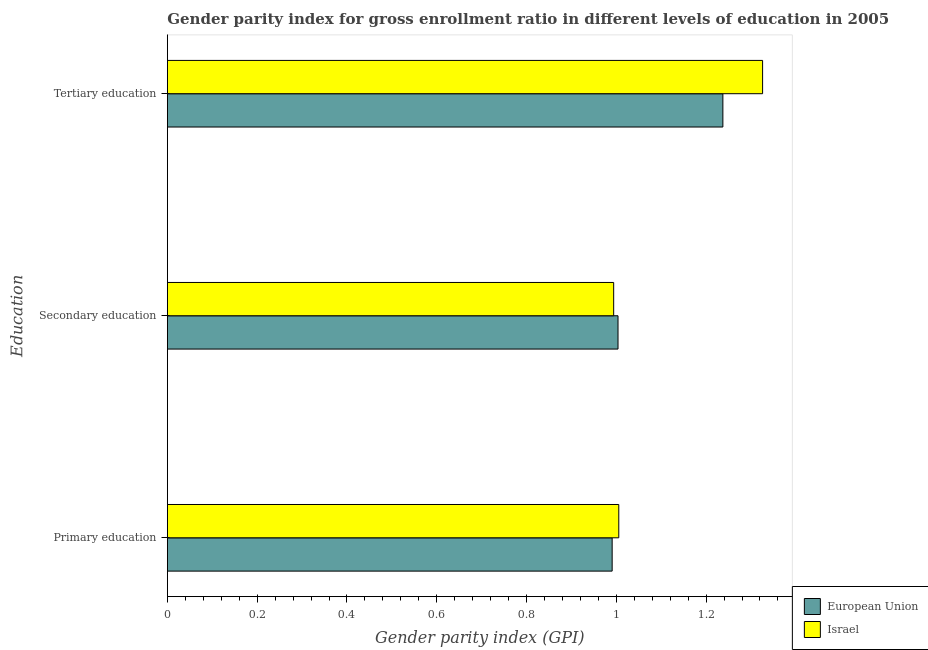How many groups of bars are there?
Provide a succinct answer. 3. Are the number of bars per tick equal to the number of legend labels?
Provide a short and direct response. Yes. How many bars are there on the 2nd tick from the top?
Your answer should be compact. 2. What is the label of the 1st group of bars from the top?
Your answer should be compact. Tertiary education. What is the gender parity index in primary education in Israel?
Offer a terse response. 1.01. Across all countries, what is the maximum gender parity index in secondary education?
Your answer should be very brief. 1. Across all countries, what is the minimum gender parity index in tertiary education?
Your answer should be very brief. 1.24. In which country was the gender parity index in secondary education maximum?
Provide a short and direct response. European Union. What is the total gender parity index in secondary education in the graph?
Your answer should be very brief. 2. What is the difference between the gender parity index in secondary education in Israel and that in European Union?
Ensure brevity in your answer.  -0.01. What is the difference between the gender parity index in secondary education in Israel and the gender parity index in primary education in European Union?
Provide a succinct answer. 0. What is the average gender parity index in tertiary education per country?
Your answer should be compact. 1.28. What is the difference between the gender parity index in primary education and gender parity index in tertiary education in Israel?
Give a very brief answer. -0.32. In how many countries, is the gender parity index in tertiary education greater than 0.04 ?
Offer a terse response. 2. What is the ratio of the gender parity index in primary education in European Union to that in Israel?
Offer a very short reply. 0.99. What is the difference between the highest and the second highest gender parity index in primary education?
Give a very brief answer. 0.01. What is the difference between the highest and the lowest gender parity index in tertiary education?
Keep it short and to the point. 0.09. In how many countries, is the gender parity index in secondary education greater than the average gender parity index in secondary education taken over all countries?
Offer a very short reply. 1. Is the sum of the gender parity index in secondary education in European Union and Israel greater than the maximum gender parity index in tertiary education across all countries?
Offer a very short reply. Yes. What does the 1st bar from the top in Primary education represents?
Give a very brief answer. Israel. How many bars are there?
Ensure brevity in your answer.  6. How many countries are there in the graph?
Your answer should be very brief. 2. Are the values on the major ticks of X-axis written in scientific E-notation?
Provide a succinct answer. No. Does the graph contain any zero values?
Provide a succinct answer. No. Does the graph contain grids?
Offer a terse response. No. Where does the legend appear in the graph?
Provide a short and direct response. Bottom right. How many legend labels are there?
Ensure brevity in your answer.  2. How are the legend labels stacked?
Your response must be concise. Vertical. What is the title of the graph?
Ensure brevity in your answer.  Gender parity index for gross enrollment ratio in different levels of education in 2005. Does "Cayman Islands" appear as one of the legend labels in the graph?
Your answer should be very brief. No. What is the label or title of the X-axis?
Your response must be concise. Gender parity index (GPI). What is the label or title of the Y-axis?
Ensure brevity in your answer.  Education. What is the Gender parity index (GPI) of European Union in Primary education?
Offer a terse response. 0.99. What is the Gender parity index (GPI) in Israel in Primary education?
Your response must be concise. 1.01. What is the Gender parity index (GPI) in European Union in Secondary education?
Provide a succinct answer. 1. What is the Gender parity index (GPI) of Israel in Secondary education?
Ensure brevity in your answer.  0.99. What is the Gender parity index (GPI) in European Union in Tertiary education?
Keep it short and to the point. 1.24. What is the Gender parity index (GPI) in Israel in Tertiary education?
Ensure brevity in your answer.  1.33. Across all Education, what is the maximum Gender parity index (GPI) of European Union?
Offer a very short reply. 1.24. Across all Education, what is the maximum Gender parity index (GPI) of Israel?
Offer a very short reply. 1.33. Across all Education, what is the minimum Gender parity index (GPI) of European Union?
Your answer should be very brief. 0.99. Across all Education, what is the minimum Gender parity index (GPI) in Israel?
Provide a short and direct response. 0.99. What is the total Gender parity index (GPI) in European Union in the graph?
Offer a very short reply. 3.23. What is the total Gender parity index (GPI) in Israel in the graph?
Your response must be concise. 3.33. What is the difference between the Gender parity index (GPI) in European Union in Primary education and that in Secondary education?
Provide a short and direct response. -0.01. What is the difference between the Gender parity index (GPI) of Israel in Primary education and that in Secondary education?
Your answer should be compact. 0.01. What is the difference between the Gender parity index (GPI) of European Union in Primary education and that in Tertiary education?
Ensure brevity in your answer.  -0.25. What is the difference between the Gender parity index (GPI) in Israel in Primary education and that in Tertiary education?
Offer a terse response. -0.32. What is the difference between the Gender parity index (GPI) in European Union in Secondary education and that in Tertiary education?
Provide a succinct answer. -0.23. What is the difference between the Gender parity index (GPI) in Israel in Secondary education and that in Tertiary education?
Offer a very short reply. -0.33. What is the difference between the Gender parity index (GPI) of European Union in Primary education and the Gender parity index (GPI) of Israel in Secondary education?
Keep it short and to the point. -0. What is the difference between the Gender parity index (GPI) of European Union in Primary education and the Gender parity index (GPI) of Israel in Tertiary education?
Provide a short and direct response. -0.34. What is the difference between the Gender parity index (GPI) in European Union in Secondary education and the Gender parity index (GPI) in Israel in Tertiary education?
Provide a short and direct response. -0.32. What is the average Gender parity index (GPI) of European Union per Education?
Keep it short and to the point. 1.08. What is the average Gender parity index (GPI) of Israel per Education?
Make the answer very short. 1.11. What is the difference between the Gender parity index (GPI) of European Union and Gender parity index (GPI) of Israel in Primary education?
Your answer should be compact. -0.01. What is the difference between the Gender parity index (GPI) of European Union and Gender parity index (GPI) of Israel in Secondary education?
Provide a short and direct response. 0.01. What is the difference between the Gender parity index (GPI) of European Union and Gender parity index (GPI) of Israel in Tertiary education?
Offer a very short reply. -0.09. What is the ratio of the Gender parity index (GPI) in European Union in Primary education to that in Secondary education?
Provide a short and direct response. 0.99. What is the ratio of the Gender parity index (GPI) in Israel in Primary education to that in Secondary education?
Provide a succinct answer. 1.01. What is the ratio of the Gender parity index (GPI) of European Union in Primary education to that in Tertiary education?
Ensure brevity in your answer.  0.8. What is the ratio of the Gender parity index (GPI) in Israel in Primary education to that in Tertiary education?
Keep it short and to the point. 0.76. What is the ratio of the Gender parity index (GPI) of European Union in Secondary education to that in Tertiary education?
Your answer should be very brief. 0.81. What is the ratio of the Gender parity index (GPI) of Israel in Secondary education to that in Tertiary education?
Your response must be concise. 0.75. What is the difference between the highest and the second highest Gender parity index (GPI) in European Union?
Keep it short and to the point. 0.23. What is the difference between the highest and the second highest Gender parity index (GPI) of Israel?
Ensure brevity in your answer.  0.32. What is the difference between the highest and the lowest Gender parity index (GPI) of European Union?
Provide a short and direct response. 0.25. What is the difference between the highest and the lowest Gender parity index (GPI) of Israel?
Your answer should be compact. 0.33. 